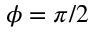Convert formula to latex. <formula><loc_0><loc_0><loc_500><loc_500>\phi = \pi / 2</formula> 